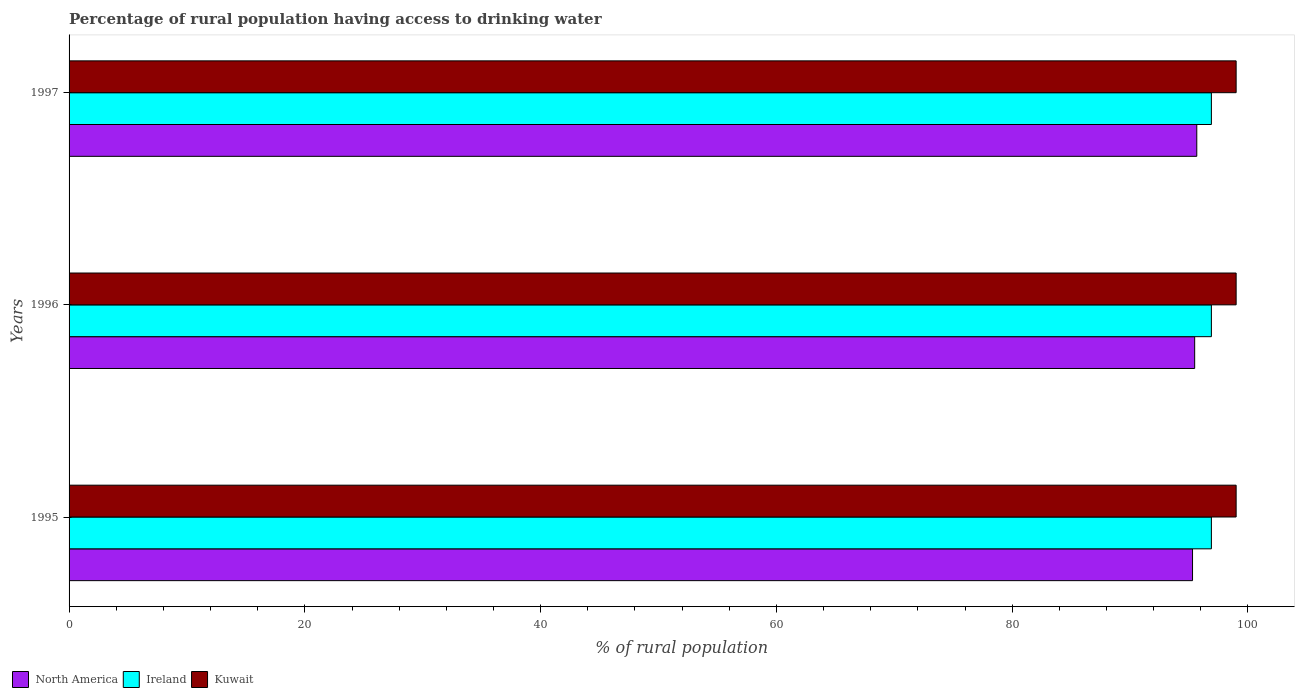How many groups of bars are there?
Provide a succinct answer. 3. Are the number of bars on each tick of the Y-axis equal?
Offer a terse response. Yes. How many bars are there on the 2nd tick from the top?
Ensure brevity in your answer.  3. What is the percentage of rural population having access to drinking water in Kuwait in 1995?
Provide a succinct answer. 99. Across all years, what is the maximum percentage of rural population having access to drinking water in Ireland?
Provide a short and direct response. 96.9. Across all years, what is the minimum percentage of rural population having access to drinking water in North America?
Offer a very short reply. 95.3. What is the total percentage of rural population having access to drinking water in North America in the graph?
Offer a terse response. 286.44. What is the difference between the percentage of rural population having access to drinking water in North America in 1996 and that in 1997?
Your answer should be very brief. -0.18. What is the difference between the percentage of rural population having access to drinking water in Kuwait in 1996 and the percentage of rural population having access to drinking water in North America in 1995?
Your response must be concise. 3.7. What is the average percentage of rural population having access to drinking water in North America per year?
Provide a short and direct response. 95.48. In the year 1997, what is the difference between the percentage of rural population having access to drinking water in Ireland and percentage of rural population having access to drinking water in Kuwait?
Ensure brevity in your answer.  -2.1. What is the ratio of the percentage of rural population having access to drinking water in North America in 1995 to that in 1996?
Your answer should be compact. 1. What is the difference between the highest and the second highest percentage of rural population having access to drinking water in Kuwait?
Your answer should be very brief. 0. What does the 1st bar from the top in 1996 represents?
Ensure brevity in your answer.  Kuwait. What does the 2nd bar from the bottom in 1997 represents?
Keep it short and to the point. Ireland. Is it the case that in every year, the sum of the percentage of rural population having access to drinking water in Kuwait and percentage of rural population having access to drinking water in Ireland is greater than the percentage of rural population having access to drinking water in North America?
Provide a short and direct response. Yes. Are all the bars in the graph horizontal?
Offer a terse response. Yes. How many years are there in the graph?
Give a very brief answer. 3. What is the difference between two consecutive major ticks on the X-axis?
Offer a terse response. 20. How many legend labels are there?
Your answer should be very brief. 3. What is the title of the graph?
Offer a terse response. Percentage of rural population having access to drinking water. Does "High income: nonOECD" appear as one of the legend labels in the graph?
Your response must be concise. No. What is the label or title of the X-axis?
Give a very brief answer. % of rural population. What is the % of rural population in North America in 1995?
Make the answer very short. 95.3. What is the % of rural population of Ireland in 1995?
Offer a very short reply. 96.9. What is the % of rural population in North America in 1996?
Your response must be concise. 95.48. What is the % of rural population of Ireland in 1996?
Your answer should be very brief. 96.9. What is the % of rural population of North America in 1997?
Your answer should be very brief. 95.66. What is the % of rural population in Ireland in 1997?
Provide a succinct answer. 96.9. Across all years, what is the maximum % of rural population of North America?
Give a very brief answer. 95.66. Across all years, what is the maximum % of rural population in Ireland?
Your answer should be very brief. 96.9. Across all years, what is the maximum % of rural population of Kuwait?
Provide a short and direct response. 99. Across all years, what is the minimum % of rural population of North America?
Ensure brevity in your answer.  95.3. Across all years, what is the minimum % of rural population in Ireland?
Your answer should be compact. 96.9. What is the total % of rural population of North America in the graph?
Make the answer very short. 286.44. What is the total % of rural population of Ireland in the graph?
Keep it short and to the point. 290.7. What is the total % of rural population in Kuwait in the graph?
Provide a short and direct response. 297. What is the difference between the % of rural population in North America in 1995 and that in 1996?
Make the answer very short. -0.18. What is the difference between the % of rural population in Ireland in 1995 and that in 1996?
Keep it short and to the point. 0. What is the difference between the % of rural population of North America in 1995 and that in 1997?
Your response must be concise. -0.36. What is the difference between the % of rural population in Ireland in 1995 and that in 1997?
Keep it short and to the point. 0. What is the difference between the % of rural population of North America in 1996 and that in 1997?
Provide a short and direct response. -0.18. What is the difference between the % of rural population of Ireland in 1996 and that in 1997?
Your answer should be very brief. 0. What is the difference between the % of rural population of North America in 1995 and the % of rural population of Ireland in 1996?
Offer a very short reply. -1.6. What is the difference between the % of rural population of North America in 1995 and the % of rural population of Kuwait in 1996?
Keep it short and to the point. -3.7. What is the difference between the % of rural population of Ireland in 1995 and the % of rural population of Kuwait in 1996?
Make the answer very short. -2.1. What is the difference between the % of rural population in North America in 1995 and the % of rural population in Ireland in 1997?
Your answer should be very brief. -1.6. What is the difference between the % of rural population of North America in 1995 and the % of rural population of Kuwait in 1997?
Make the answer very short. -3.7. What is the difference between the % of rural population of North America in 1996 and the % of rural population of Ireland in 1997?
Your response must be concise. -1.42. What is the difference between the % of rural population in North America in 1996 and the % of rural population in Kuwait in 1997?
Give a very brief answer. -3.52. What is the average % of rural population in North America per year?
Offer a terse response. 95.48. What is the average % of rural population of Ireland per year?
Ensure brevity in your answer.  96.9. What is the average % of rural population in Kuwait per year?
Offer a very short reply. 99. In the year 1995, what is the difference between the % of rural population of North America and % of rural population of Ireland?
Offer a very short reply. -1.6. In the year 1995, what is the difference between the % of rural population in North America and % of rural population in Kuwait?
Offer a very short reply. -3.7. In the year 1996, what is the difference between the % of rural population of North America and % of rural population of Ireland?
Your answer should be compact. -1.42. In the year 1996, what is the difference between the % of rural population in North America and % of rural population in Kuwait?
Ensure brevity in your answer.  -3.52. In the year 1997, what is the difference between the % of rural population of North America and % of rural population of Ireland?
Ensure brevity in your answer.  -1.24. In the year 1997, what is the difference between the % of rural population of North America and % of rural population of Kuwait?
Offer a very short reply. -3.34. In the year 1997, what is the difference between the % of rural population in Ireland and % of rural population in Kuwait?
Keep it short and to the point. -2.1. What is the ratio of the % of rural population of North America in 1995 to that in 1996?
Offer a terse response. 1. What is the ratio of the % of rural population in Ireland in 1995 to that in 1996?
Give a very brief answer. 1. What is the ratio of the % of rural population in Ireland in 1995 to that in 1997?
Your answer should be very brief. 1. What is the ratio of the % of rural population of Kuwait in 1995 to that in 1997?
Provide a succinct answer. 1. What is the ratio of the % of rural population in Ireland in 1996 to that in 1997?
Give a very brief answer. 1. What is the difference between the highest and the second highest % of rural population of North America?
Offer a terse response. 0.18. What is the difference between the highest and the second highest % of rural population in Ireland?
Ensure brevity in your answer.  0. What is the difference between the highest and the second highest % of rural population of Kuwait?
Your response must be concise. 0. What is the difference between the highest and the lowest % of rural population in North America?
Your answer should be very brief. 0.36. What is the difference between the highest and the lowest % of rural population in Ireland?
Make the answer very short. 0. 